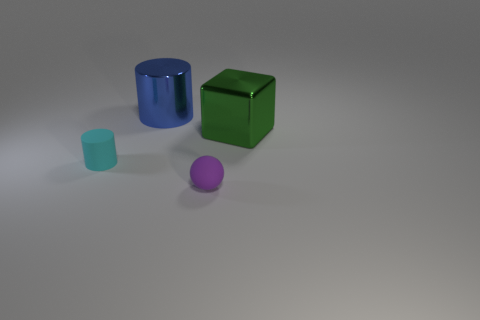Are there any other small matte things that have the same shape as the blue thing?
Your answer should be compact. Yes. Is the number of spheres that are left of the green thing greater than the number of big gray metallic balls?
Keep it short and to the point. Yes. How many shiny things are large green cubes or big cyan balls?
Ensure brevity in your answer.  1. There is a object that is both on the left side of the green shiny thing and behind the cyan rubber cylinder; what size is it?
Offer a very short reply. Large. There is a large blue cylinder behind the green object; is there a matte cylinder that is to the right of it?
Offer a very short reply. No. What number of large metal things are behind the big green metal object?
Offer a terse response. 1. What color is the other tiny object that is the same shape as the blue object?
Provide a succinct answer. Cyan. Are the thing right of the purple matte object and the cylinder that is behind the green metallic block made of the same material?
Keep it short and to the point. Yes. What is the shape of the object that is to the right of the matte cylinder and in front of the big green block?
Make the answer very short. Sphere. What number of cylinders are there?
Your answer should be compact. 2. 